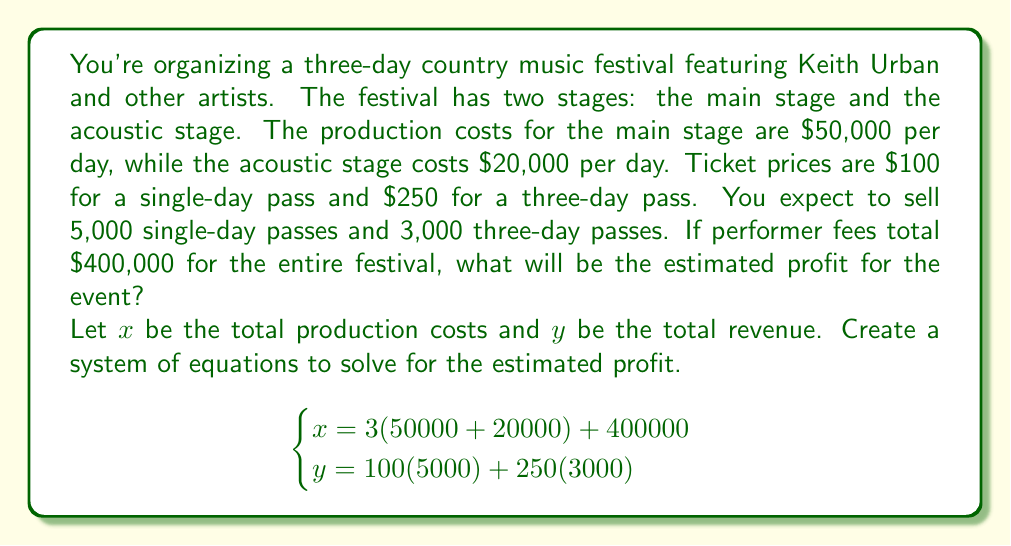Help me with this question. To solve this problem, we need to calculate the total production costs and total revenue, then find the difference to determine the profit.

1. Calculate total production costs ($x$):
   $$x = 3(50000 + 20000) + 400000$$
   $$x = 3(70000) + 400000$$
   $$x = 210000 + 400000 = 610000$$

2. Calculate total revenue ($y$):
   $$y = 100(5000) + 250(3000)$$
   $$y = 500000 + 750000 = 1250000$$

3. Calculate the profit by subtracting total costs from total revenue:
   $$\text{Profit} = y - x$$
   $$\text{Profit} = 1250000 - 610000 = 640000$$

Therefore, the estimated profit for the country music festival is $640,000.
Answer: $640,000 